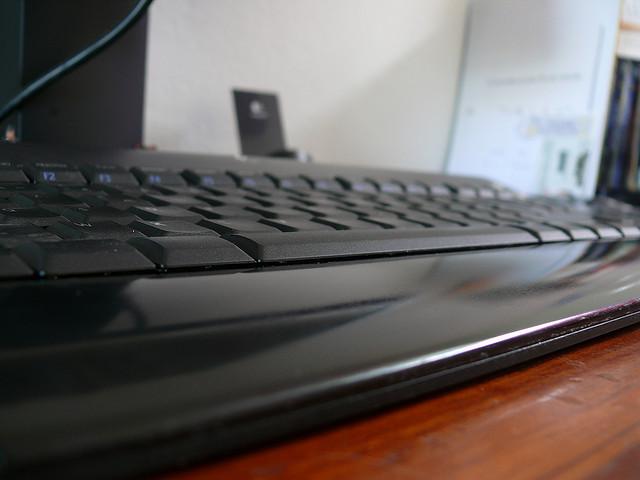What kind of table is the keyboard on?
Be succinct. Wood. Is the background clear?
Give a very brief answer. No. What's the furthest left F key you can read?
Give a very brief answer. F2. 